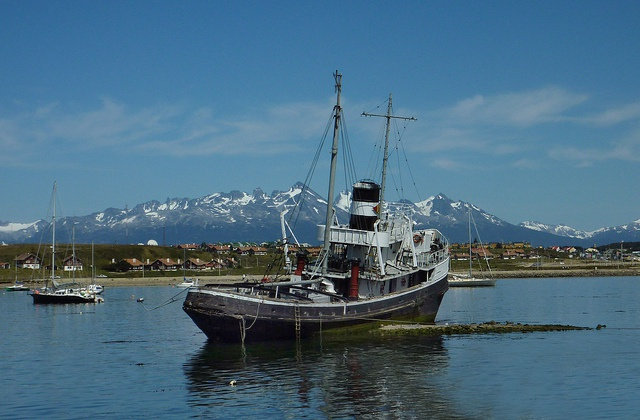Describe the objects in this image and their specific colors. I can see boat in blue, black, gray, and darkgray tones, boat in blue, black, gray, and darkgreen tones, boat in blue, gray, black, and darkgray tones, boat in blue, darkgray, gray, lightgray, and black tones, and boat in blue, black, darkgray, teal, and gray tones in this image. 